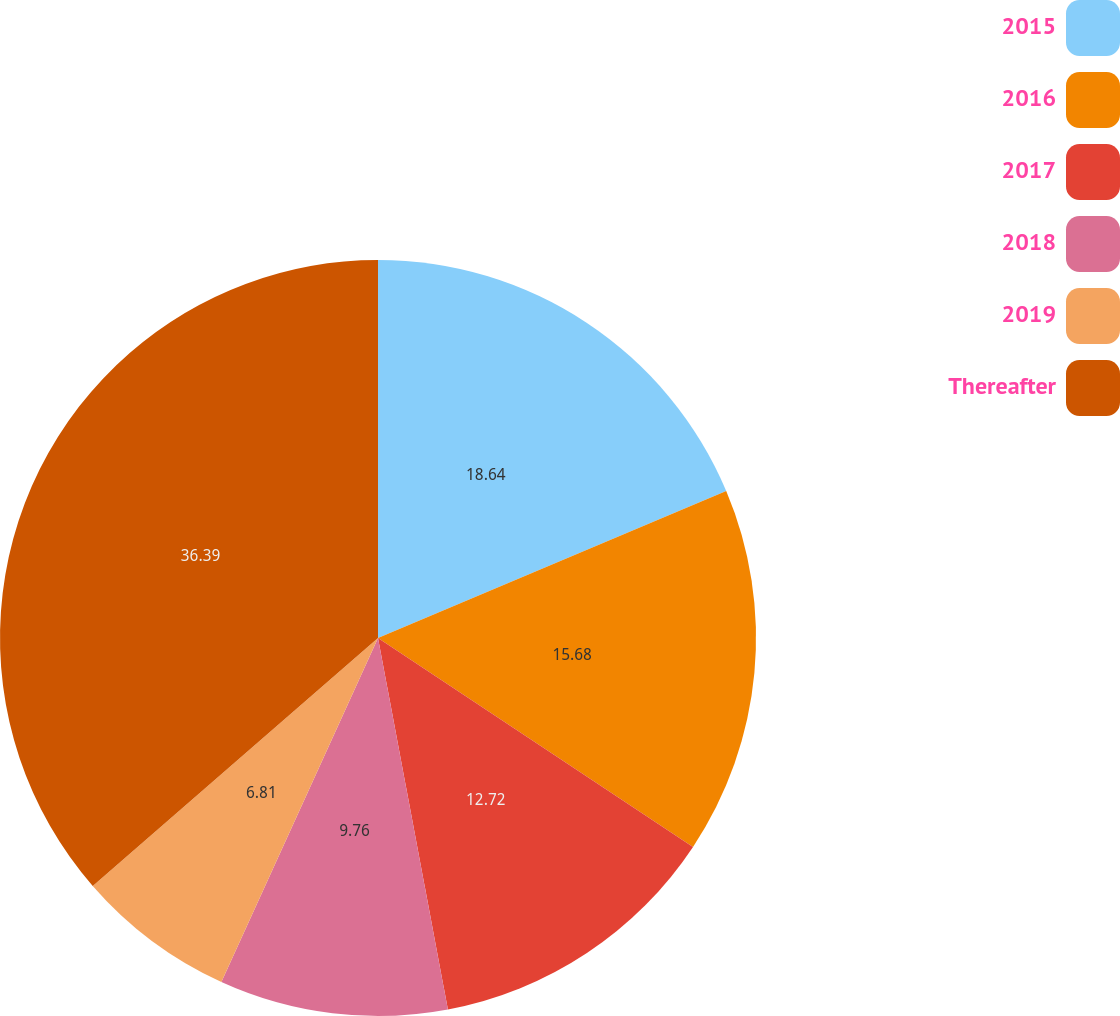Convert chart to OTSL. <chart><loc_0><loc_0><loc_500><loc_500><pie_chart><fcel>2015<fcel>2016<fcel>2017<fcel>2018<fcel>2019<fcel>Thereafter<nl><fcel>18.64%<fcel>15.68%<fcel>12.72%<fcel>9.76%<fcel>6.81%<fcel>36.39%<nl></chart> 